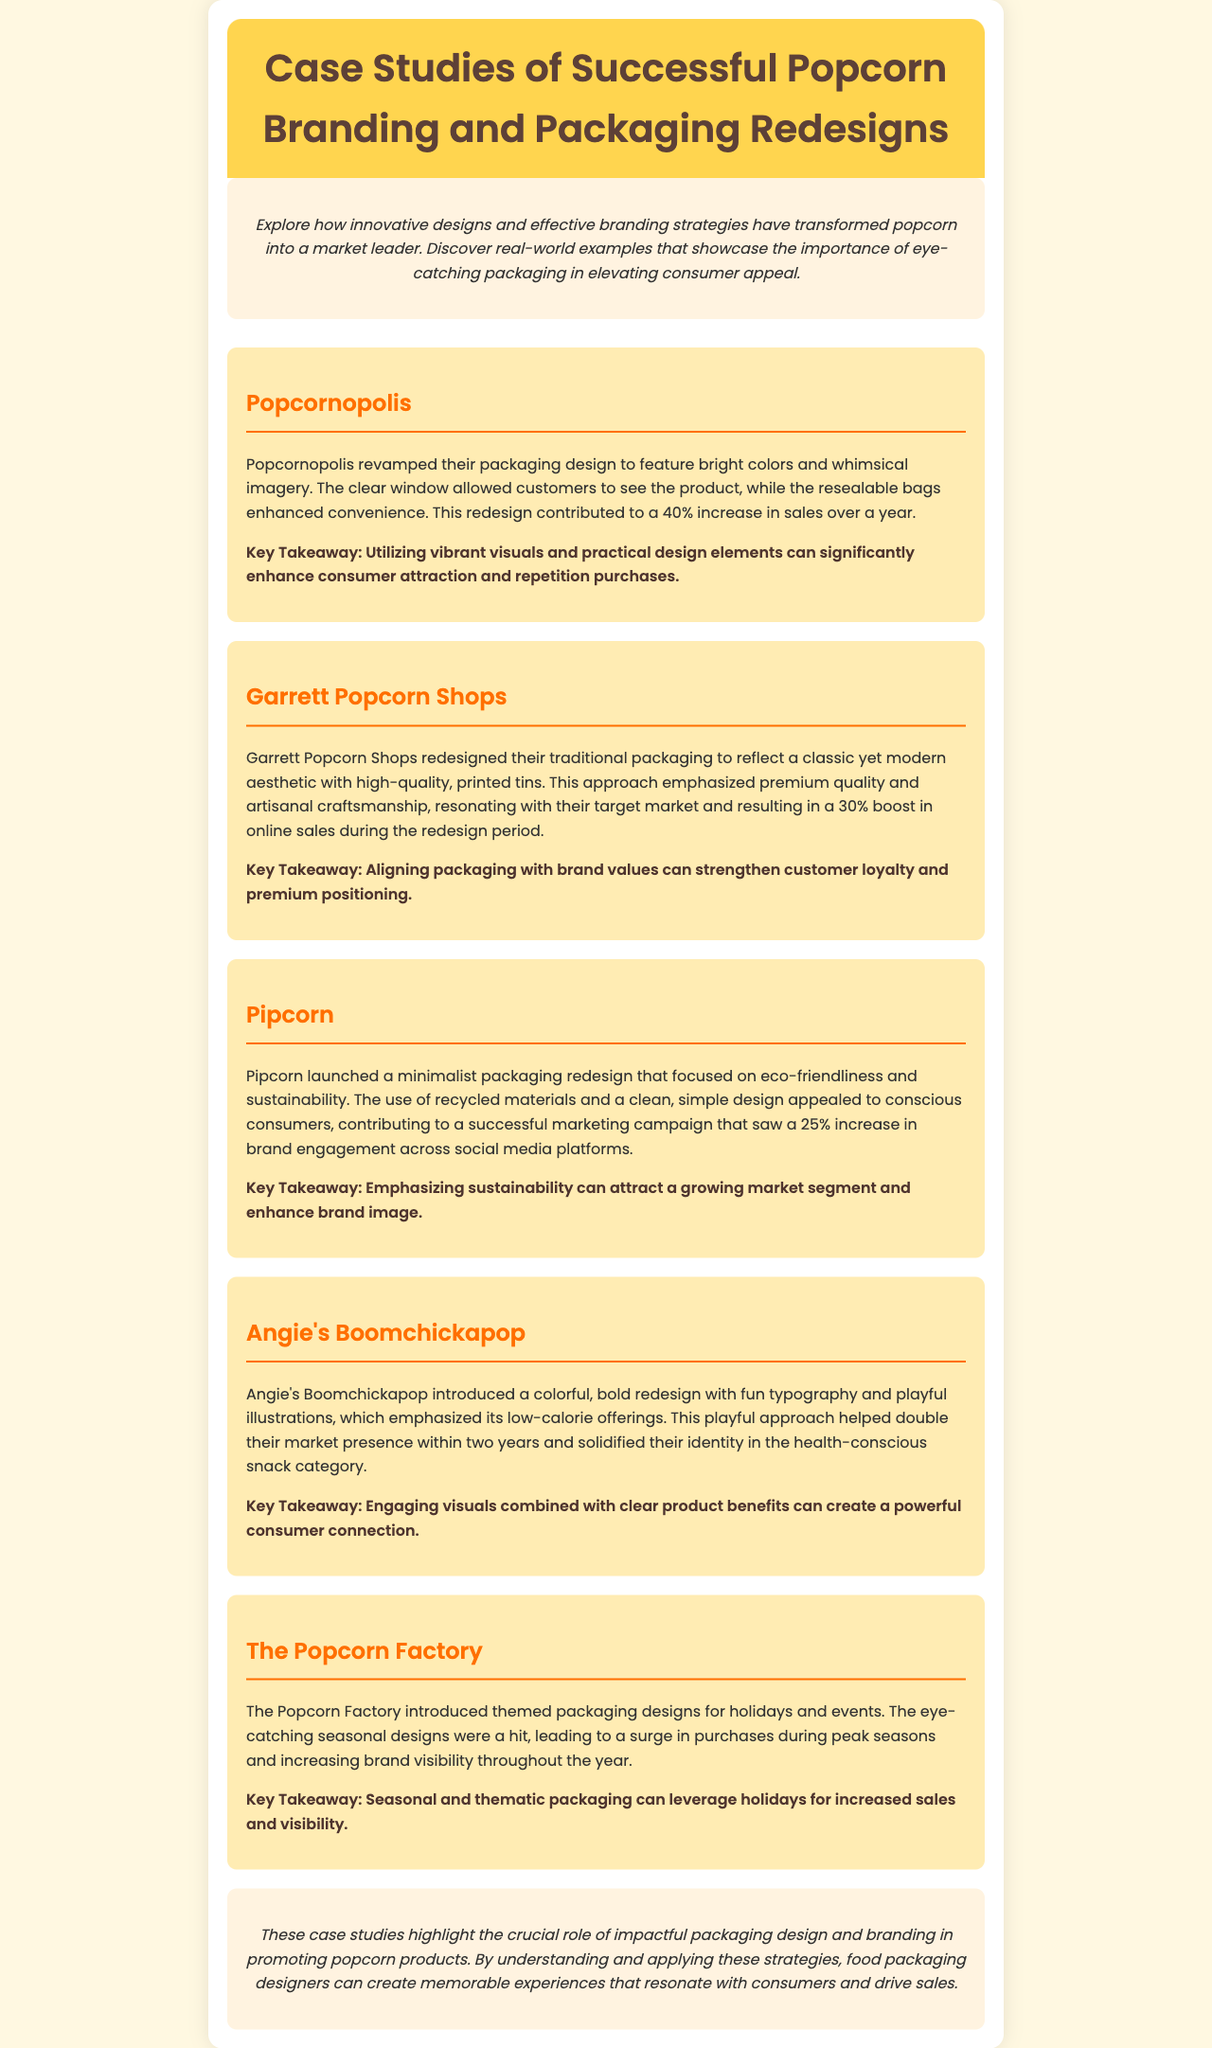what was the sales increase for Popcornopolis? Popcornopolis experienced a 40% increase in sales after their packaging redesign.
Answer: 40% what brand emphasized recycled materials in their packaging? Pipcorn focused on eco-friendliness and sustainability by using recycled materials in their redesign.
Answer: Pipcorn which brand's redesign led to a 30% boost in online sales? Garrett Popcorn Shops saw a 30% boost in online sales attributed to their packaging redesign.
Answer: Garrett Popcorn Shops what is a key takeaway from Angie's Boomchickapop case study? The key takeaway highlights that engaging visuals combined with clear product benefits create a powerful consumer connection.
Answer: Engaging visuals how did themed packaging impact The Popcorn Factory's sales? The themed packaging designs introduced by The Popcorn Factory led to a surge in purchases during peak seasons.
Answer: Increased purchases what design style did Pipcorn adopt in their packaging? Pipcorn adopted a minimalist design style focused on eco-friendliness.
Answer: Minimalist how much did Angie's Boomchickapop double their market presence? Angie's Boomchickapop doubled their market presence within two years after their redesign.
Answer: Doubled what element contributed to Popcornopolis’s consumer attraction? Vibrant visuals and practical design elements significantly enhanced consumer attraction for Popcornopolis.
Answer: Vibrant visuals what is the overall theme of the newsletter? The newsletter discusses successful popcorn branding and packaging redesigns that elevate consumer appeal.
Answer: Successful branding 